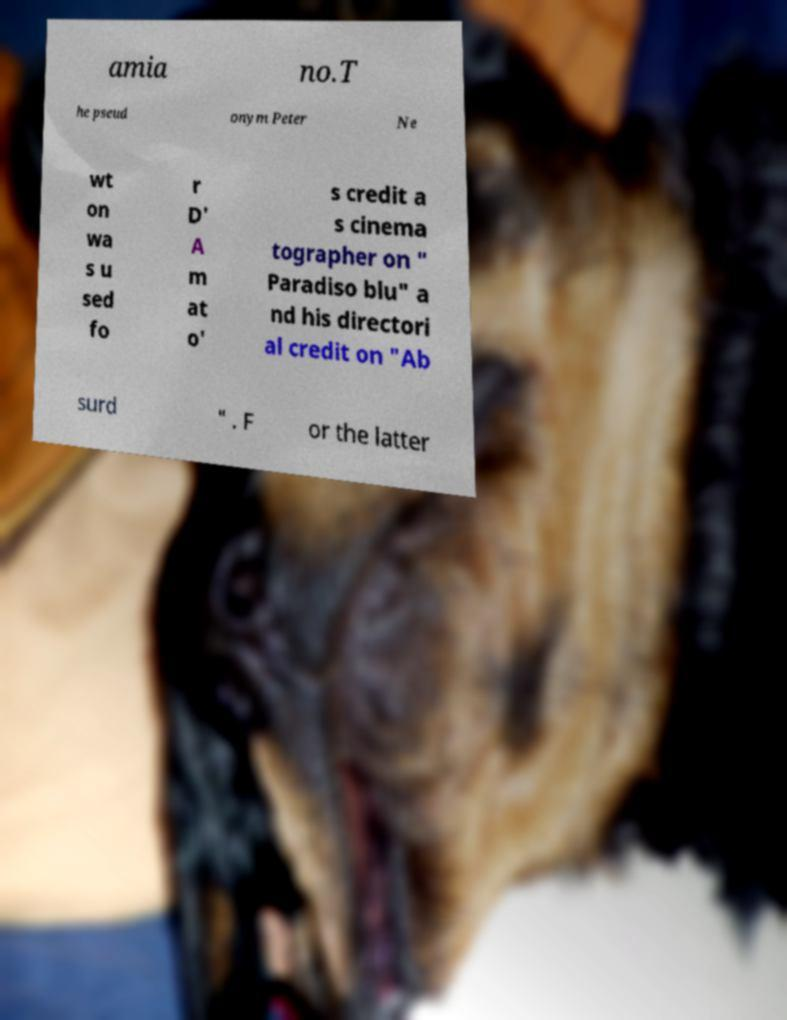I need the written content from this picture converted into text. Can you do that? amia no.T he pseud onym Peter Ne wt on wa s u sed fo r D' A m at o' s credit a s cinema tographer on " Paradiso blu" a nd his directori al credit on "Ab surd " . F or the latter 